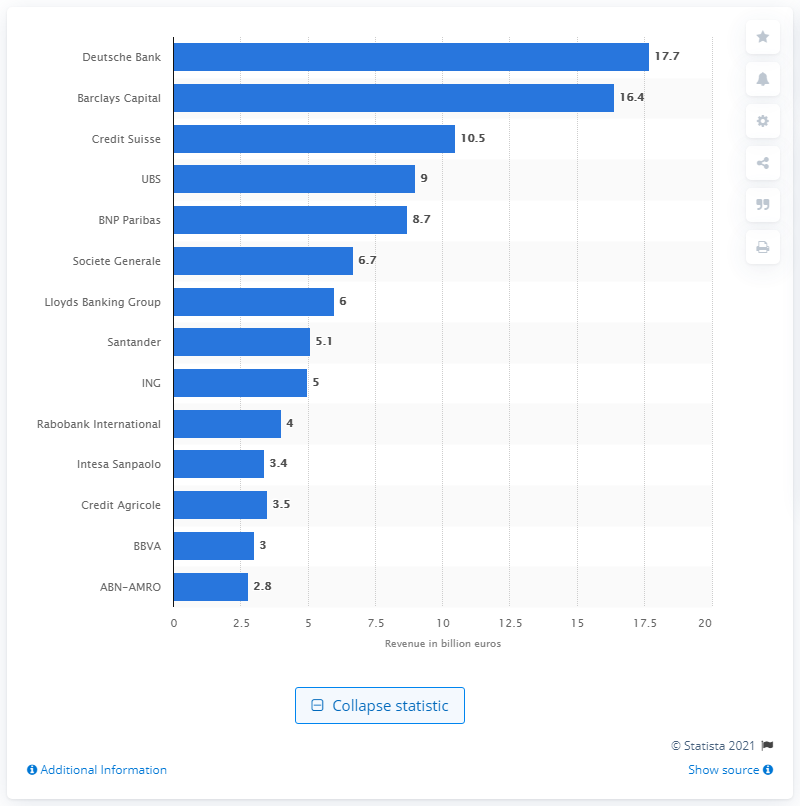Give some essential details in this illustration. In 2013, the revenue of Deutsche Bank's Capital Markets Investment Banking (CIB) division was 17.7 billion US dollars. 